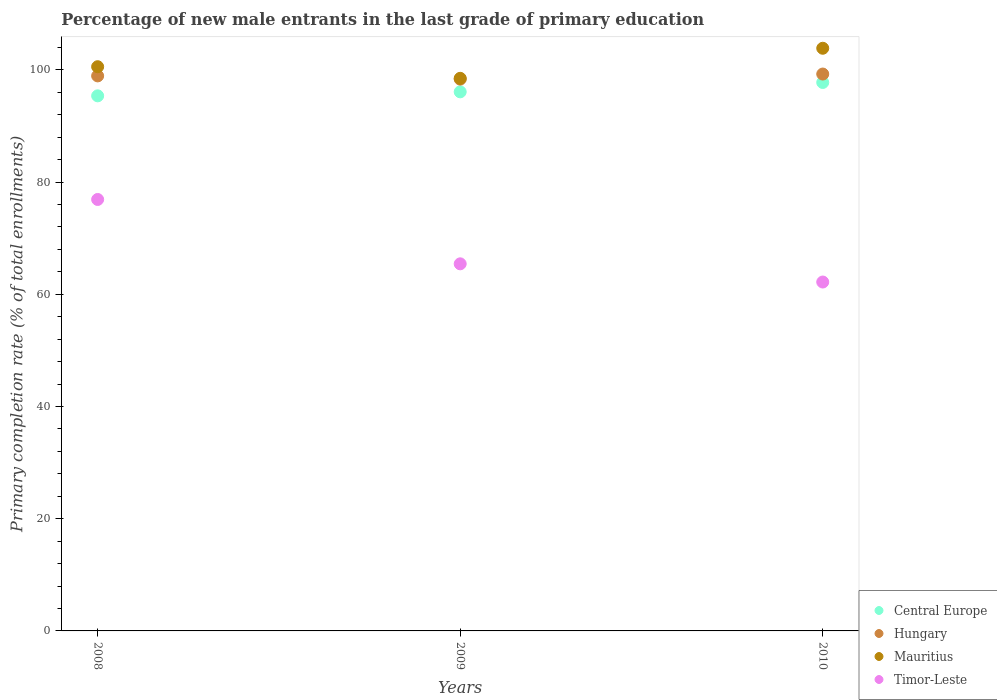Is the number of dotlines equal to the number of legend labels?
Give a very brief answer. Yes. What is the percentage of new male entrants in Central Europe in 2010?
Your answer should be very brief. 97.76. Across all years, what is the maximum percentage of new male entrants in Timor-Leste?
Provide a succinct answer. 76.9. Across all years, what is the minimum percentage of new male entrants in Hungary?
Offer a terse response. 98.35. In which year was the percentage of new male entrants in Central Europe maximum?
Your response must be concise. 2010. In which year was the percentage of new male entrants in Central Europe minimum?
Provide a short and direct response. 2008. What is the total percentage of new male entrants in Central Europe in the graph?
Offer a terse response. 289.22. What is the difference between the percentage of new male entrants in Mauritius in 2008 and that in 2009?
Offer a very short reply. 2.07. What is the difference between the percentage of new male entrants in Timor-Leste in 2009 and the percentage of new male entrants in Central Europe in 2010?
Make the answer very short. -32.32. What is the average percentage of new male entrants in Central Europe per year?
Your response must be concise. 96.41. In the year 2009, what is the difference between the percentage of new male entrants in Mauritius and percentage of new male entrants in Central Europe?
Offer a terse response. 2.41. What is the ratio of the percentage of new male entrants in Mauritius in 2008 to that in 2009?
Ensure brevity in your answer.  1.02. What is the difference between the highest and the second highest percentage of new male entrants in Hungary?
Provide a succinct answer. 0.33. What is the difference between the highest and the lowest percentage of new male entrants in Hungary?
Offer a very short reply. 0.91. Is it the case that in every year, the sum of the percentage of new male entrants in Mauritius and percentage of new male entrants in Timor-Leste  is greater than the sum of percentage of new male entrants in Hungary and percentage of new male entrants in Central Europe?
Offer a terse response. No. Is the percentage of new male entrants in Mauritius strictly greater than the percentage of new male entrants in Hungary over the years?
Provide a succinct answer. Yes. Is the percentage of new male entrants in Hungary strictly less than the percentage of new male entrants in Mauritius over the years?
Provide a short and direct response. Yes. What is the difference between two consecutive major ticks on the Y-axis?
Your response must be concise. 20. Does the graph contain any zero values?
Your answer should be very brief. No. Does the graph contain grids?
Your answer should be very brief. No. How many legend labels are there?
Offer a very short reply. 4. How are the legend labels stacked?
Make the answer very short. Vertical. What is the title of the graph?
Offer a terse response. Percentage of new male entrants in the last grade of primary education. What is the label or title of the X-axis?
Your response must be concise. Years. What is the label or title of the Y-axis?
Make the answer very short. Primary completion rate (% of total enrollments). What is the Primary completion rate (% of total enrollments) of Central Europe in 2008?
Offer a very short reply. 95.38. What is the Primary completion rate (% of total enrollments) in Hungary in 2008?
Give a very brief answer. 98.93. What is the Primary completion rate (% of total enrollments) of Mauritius in 2008?
Offer a very short reply. 100.57. What is the Primary completion rate (% of total enrollments) in Timor-Leste in 2008?
Offer a terse response. 76.9. What is the Primary completion rate (% of total enrollments) of Central Europe in 2009?
Provide a succinct answer. 96.09. What is the Primary completion rate (% of total enrollments) of Hungary in 2009?
Ensure brevity in your answer.  98.35. What is the Primary completion rate (% of total enrollments) in Mauritius in 2009?
Provide a succinct answer. 98.5. What is the Primary completion rate (% of total enrollments) of Timor-Leste in 2009?
Your answer should be compact. 65.43. What is the Primary completion rate (% of total enrollments) of Central Europe in 2010?
Provide a succinct answer. 97.76. What is the Primary completion rate (% of total enrollments) in Hungary in 2010?
Your answer should be very brief. 99.26. What is the Primary completion rate (% of total enrollments) of Mauritius in 2010?
Offer a very short reply. 103.86. What is the Primary completion rate (% of total enrollments) in Timor-Leste in 2010?
Make the answer very short. 62.19. Across all years, what is the maximum Primary completion rate (% of total enrollments) of Central Europe?
Offer a very short reply. 97.76. Across all years, what is the maximum Primary completion rate (% of total enrollments) in Hungary?
Make the answer very short. 99.26. Across all years, what is the maximum Primary completion rate (% of total enrollments) in Mauritius?
Offer a very short reply. 103.86. Across all years, what is the maximum Primary completion rate (% of total enrollments) of Timor-Leste?
Provide a succinct answer. 76.9. Across all years, what is the minimum Primary completion rate (% of total enrollments) in Central Europe?
Ensure brevity in your answer.  95.38. Across all years, what is the minimum Primary completion rate (% of total enrollments) of Hungary?
Provide a succinct answer. 98.35. Across all years, what is the minimum Primary completion rate (% of total enrollments) of Mauritius?
Give a very brief answer. 98.5. Across all years, what is the minimum Primary completion rate (% of total enrollments) in Timor-Leste?
Provide a short and direct response. 62.19. What is the total Primary completion rate (% of total enrollments) in Central Europe in the graph?
Keep it short and to the point. 289.22. What is the total Primary completion rate (% of total enrollments) of Hungary in the graph?
Your answer should be compact. 296.55. What is the total Primary completion rate (% of total enrollments) of Mauritius in the graph?
Offer a terse response. 302.92. What is the total Primary completion rate (% of total enrollments) in Timor-Leste in the graph?
Make the answer very short. 204.53. What is the difference between the Primary completion rate (% of total enrollments) in Central Europe in 2008 and that in 2009?
Keep it short and to the point. -0.71. What is the difference between the Primary completion rate (% of total enrollments) in Hungary in 2008 and that in 2009?
Provide a succinct answer. 0.58. What is the difference between the Primary completion rate (% of total enrollments) of Mauritius in 2008 and that in 2009?
Provide a succinct answer. 2.07. What is the difference between the Primary completion rate (% of total enrollments) of Timor-Leste in 2008 and that in 2009?
Your answer should be compact. 11.47. What is the difference between the Primary completion rate (% of total enrollments) in Central Europe in 2008 and that in 2010?
Ensure brevity in your answer.  -2.38. What is the difference between the Primary completion rate (% of total enrollments) of Hungary in 2008 and that in 2010?
Your answer should be very brief. -0.33. What is the difference between the Primary completion rate (% of total enrollments) in Mauritius in 2008 and that in 2010?
Offer a terse response. -3.29. What is the difference between the Primary completion rate (% of total enrollments) of Timor-Leste in 2008 and that in 2010?
Offer a very short reply. 14.72. What is the difference between the Primary completion rate (% of total enrollments) in Central Europe in 2009 and that in 2010?
Offer a terse response. -1.67. What is the difference between the Primary completion rate (% of total enrollments) of Hungary in 2009 and that in 2010?
Your answer should be compact. -0.91. What is the difference between the Primary completion rate (% of total enrollments) of Mauritius in 2009 and that in 2010?
Your answer should be compact. -5.36. What is the difference between the Primary completion rate (% of total enrollments) in Timor-Leste in 2009 and that in 2010?
Your response must be concise. 3.24. What is the difference between the Primary completion rate (% of total enrollments) of Central Europe in 2008 and the Primary completion rate (% of total enrollments) of Hungary in 2009?
Provide a succinct answer. -2.98. What is the difference between the Primary completion rate (% of total enrollments) in Central Europe in 2008 and the Primary completion rate (% of total enrollments) in Mauritius in 2009?
Offer a terse response. -3.12. What is the difference between the Primary completion rate (% of total enrollments) in Central Europe in 2008 and the Primary completion rate (% of total enrollments) in Timor-Leste in 2009?
Offer a very short reply. 29.94. What is the difference between the Primary completion rate (% of total enrollments) in Hungary in 2008 and the Primary completion rate (% of total enrollments) in Mauritius in 2009?
Provide a succinct answer. 0.43. What is the difference between the Primary completion rate (% of total enrollments) of Hungary in 2008 and the Primary completion rate (% of total enrollments) of Timor-Leste in 2009?
Your answer should be very brief. 33.5. What is the difference between the Primary completion rate (% of total enrollments) in Mauritius in 2008 and the Primary completion rate (% of total enrollments) in Timor-Leste in 2009?
Your response must be concise. 35.13. What is the difference between the Primary completion rate (% of total enrollments) of Central Europe in 2008 and the Primary completion rate (% of total enrollments) of Hungary in 2010?
Offer a very short reply. -3.89. What is the difference between the Primary completion rate (% of total enrollments) in Central Europe in 2008 and the Primary completion rate (% of total enrollments) in Mauritius in 2010?
Offer a terse response. -8.48. What is the difference between the Primary completion rate (% of total enrollments) in Central Europe in 2008 and the Primary completion rate (% of total enrollments) in Timor-Leste in 2010?
Your answer should be very brief. 33.19. What is the difference between the Primary completion rate (% of total enrollments) of Hungary in 2008 and the Primary completion rate (% of total enrollments) of Mauritius in 2010?
Provide a succinct answer. -4.92. What is the difference between the Primary completion rate (% of total enrollments) in Hungary in 2008 and the Primary completion rate (% of total enrollments) in Timor-Leste in 2010?
Your response must be concise. 36.74. What is the difference between the Primary completion rate (% of total enrollments) of Mauritius in 2008 and the Primary completion rate (% of total enrollments) of Timor-Leste in 2010?
Offer a terse response. 38.38. What is the difference between the Primary completion rate (% of total enrollments) in Central Europe in 2009 and the Primary completion rate (% of total enrollments) in Hungary in 2010?
Provide a succinct answer. -3.17. What is the difference between the Primary completion rate (% of total enrollments) of Central Europe in 2009 and the Primary completion rate (% of total enrollments) of Mauritius in 2010?
Make the answer very short. -7.77. What is the difference between the Primary completion rate (% of total enrollments) of Central Europe in 2009 and the Primary completion rate (% of total enrollments) of Timor-Leste in 2010?
Your answer should be very brief. 33.9. What is the difference between the Primary completion rate (% of total enrollments) in Hungary in 2009 and the Primary completion rate (% of total enrollments) in Mauritius in 2010?
Provide a short and direct response. -5.5. What is the difference between the Primary completion rate (% of total enrollments) of Hungary in 2009 and the Primary completion rate (% of total enrollments) of Timor-Leste in 2010?
Keep it short and to the point. 36.17. What is the difference between the Primary completion rate (% of total enrollments) in Mauritius in 2009 and the Primary completion rate (% of total enrollments) in Timor-Leste in 2010?
Ensure brevity in your answer.  36.31. What is the average Primary completion rate (% of total enrollments) in Central Europe per year?
Offer a very short reply. 96.41. What is the average Primary completion rate (% of total enrollments) in Hungary per year?
Your answer should be very brief. 98.85. What is the average Primary completion rate (% of total enrollments) of Mauritius per year?
Keep it short and to the point. 100.97. What is the average Primary completion rate (% of total enrollments) of Timor-Leste per year?
Give a very brief answer. 68.18. In the year 2008, what is the difference between the Primary completion rate (% of total enrollments) of Central Europe and Primary completion rate (% of total enrollments) of Hungary?
Provide a short and direct response. -3.56. In the year 2008, what is the difference between the Primary completion rate (% of total enrollments) in Central Europe and Primary completion rate (% of total enrollments) in Mauritius?
Make the answer very short. -5.19. In the year 2008, what is the difference between the Primary completion rate (% of total enrollments) in Central Europe and Primary completion rate (% of total enrollments) in Timor-Leste?
Provide a short and direct response. 18.47. In the year 2008, what is the difference between the Primary completion rate (% of total enrollments) of Hungary and Primary completion rate (% of total enrollments) of Mauritius?
Your answer should be compact. -1.64. In the year 2008, what is the difference between the Primary completion rate (% of total enrollments) of Hungary and Primary completion rate (% of total enrollments) of Timor-Leste?
Your answer should be very brief. 22.03. In the year 2008, what is the difference between the Primary completion rate (% of total enrollments) in Mauritius and Primary completion rate (% of total enrollments) in Timor-Leste?
Provide a succinct answer. 23.66. In the year 2009, what is the difference between the Primary completion rate (% of total enrollments) in Central Europe and Primary completion rate (% of total enrollments) in Hungary?
Make the answer very short. -2.27. In the year 2009, what is the difference between the Primary completion rate (% of total enrollments) of Central Europe and Primary completion rate (% of total enrollments) of Mauritius?
Your answer should be very brief. -2.41. In the year 2009, what is the difference between the Primary completion rate (% of total enrollments) of Central Europe and Primary completion rate (% of total enrollments) of Timor-Leste?
Your response must be concise. 30.66. In the year 2009, what is the difference between the Primary completion rate (% of total enrollments) of Hungary and Primary completion rate (% of total enrollments) of Mauritius?
Provide a short and direct response. -0.14. In the year 2009, what is the difference between the Primary completion rate (% of total enrollments) of Hungary and Primary completion rate (% of total enrollments) of Timor-Leste?
Provide a short and direct response. 32.92. In the year 2009, what is the difference between the Primary completion rate (% of total enrollments) of Mauritius and Primary completion rate (% of total enrollments) of Timor-Leste?
Provide a short and direct response. 33.07. In the year 2010, what is the difference between the Primary completion rate (% of total enrollments) of Central Europe and Primary completion rate (% of total enrollments) of Hungary?
Provide a short and direct response. -1.5. In the year 2010, what is the difference between the Primary completion rate (% of total enrollments) in Central Europe and Primary completion rate (% of total enrollments) in Mauritius?
Make the answer very short. -6.1. In the year 2010, what is the difference between the Primary completion rate (% of total enrollments) in Central Europe and Primary completion rate (% of total enrollments) in Timor-Leste?
Offer a very short reply. 35.57. In the year 2010, what is the difference between the Primary completion rate (% of total enrollments) of Hungary and Primary completion rate (% of total enrollments) of Mauritius?
Your answer should be very brief. -4.59. In the year 2010, what is the difference between the Primary completion rate (% of total enrollments) of Hungary and Primary completion rate (% of total enrollments) of Timor-Leste?
Your answer should be compact. 37.07. In the year 2010, what is the difference between the Primary completion rate (% of total enrollments) in Mauritius and Primary completion rate (% of total enrollments) in Timor-Leste?
Make the answer very short. 41.67. What is the ratio of the Primary completion rate (% of total enrollments) of Hungary in 2008 to that in 2009?
Give a very brief answer. 1.01. What is the ratio of the Primary completion rate (% of total enrollments) of Mauritius in 2008 to that in 2009?
Make the answer very short. 1.02. What is the ratio of the Primary completion rate (% of total enrollments) in Timor-Leste in 2008 to that in 2009?
Offer a very short reply. 1.18. What is the ratio of the Primary completion rate (% of total enrollments) of Central Europe in 2008 to that in 2010?
Give a very brief answer. 0.98. What is the ratio of the Primary completion rate (% of total enrollments) of Mauritius in 2008 to that in 2010?
Your answer should be compact. 0.97. What is the ratio of the Primary completion rate (% of total enrollments) of Timor-Leste in 2008 to that in 2010?
Keep it short and to the point. 1.24. What is the ratio of the Primary completion rate (% of total enrollments) of Central Europe in 2009 to that in 2010?
Provide a short and direct response. 0.98. What is the ratio of the Primary completion rate (% of total enrollments) of Hungary in 2009 to that in 2010?
Make the answer very short. 0.99. What is the ratio of the Primary completion rate (% of total enrollments) of Mauritius in 2009 to that in 2010?
Ensure brevity in your answer.  0.95. What is the ratio of the Primary completion rate (% of total enrollments) in Timor-Leste in 2009 to that in 2010?
Keep it short and to the point. 1.05. What is the difference between the highest and the second highest Primary completion rate (% of total enrollments) of Central Europe?
Provide a short and direct response. 1.67. What is the difference between the highest and the second highest Primary completion rate (% of total enrollments) in Hungary?
Offer a terse response. 0.33. What is the difference between the highest and the second highest Primary completion rate (% of total enrollments) in Mauritius?
Your answer should be very brief. 3.29. What is the difference between the highest and the second highest Primary completion rate (% of total enrollments) in Timor-Leste?
Make the answer very short. 11.47. What is the difference between the highest and the lowest Primary completion rate (% of total enrollments) of Central Europe?
Your response must be concise. 2.38. What is the difference between the highest and the lowest Primary completion rate (% of total enrollments) in Hungary?
Make the answer very short. 0.91. What is the difference between the highest and the lowest Primary completion rate (% of total enrollments) in Mauritius?
Ensure brevity in your answer.  5.36. What is the difference between the highest and the lowest Primary completion rate (% of total enrollments) of Timor-Leste?
Provide a short and direct response. 14.72. 